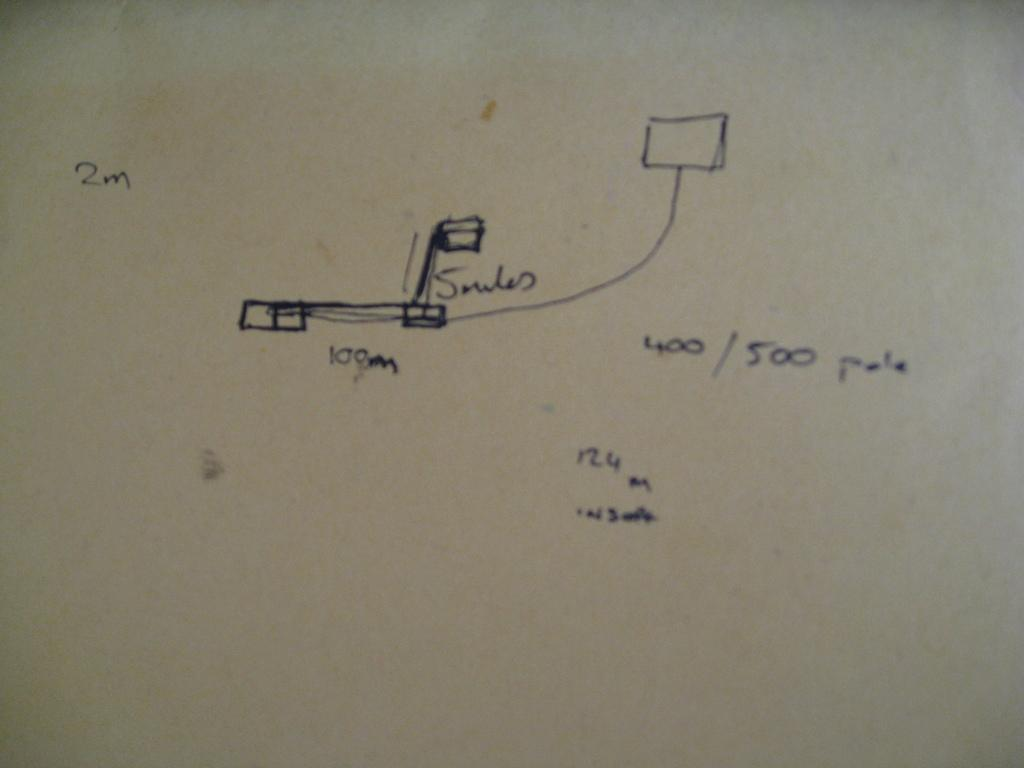<image>
Describe the image concisely. A rough design sketch that includes a 400/500 pole. 